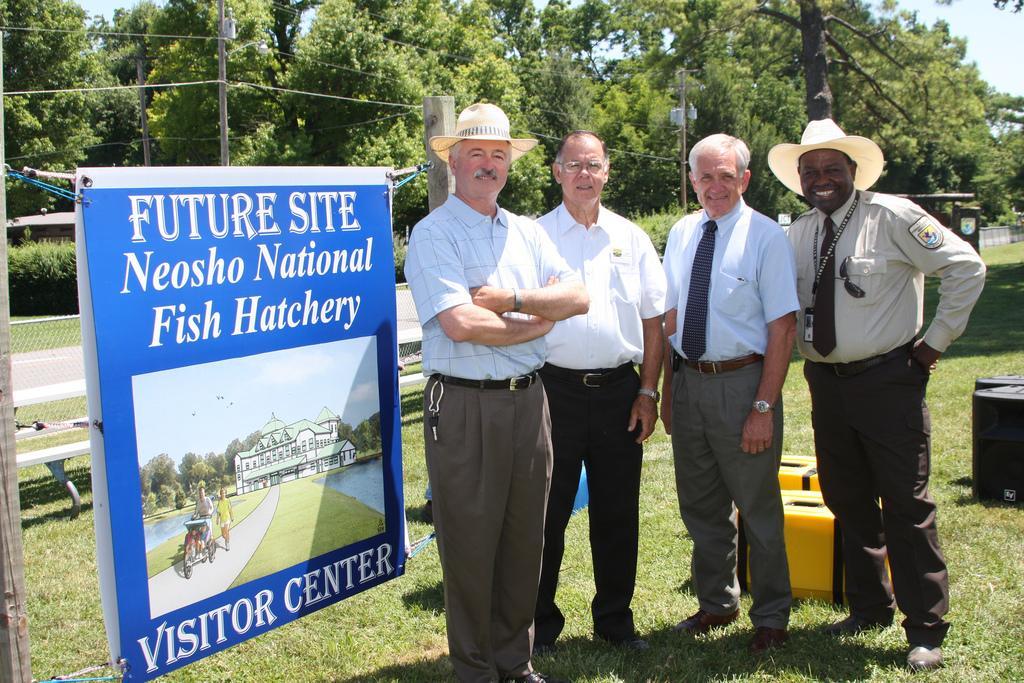Please provide a concise description of this image. In this image in the center there are persons standing and smiling and in the front there is a board with some text and images on it. In the background there are trees, there is grass on the ground, there are objects on the ground which are yellow, black and blue in colour and there is an empty bench. 